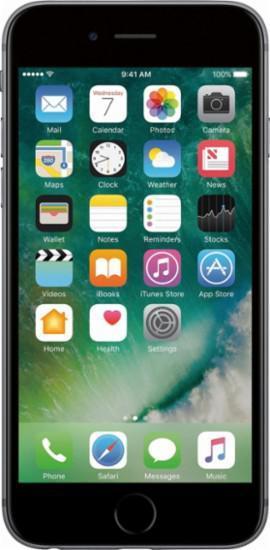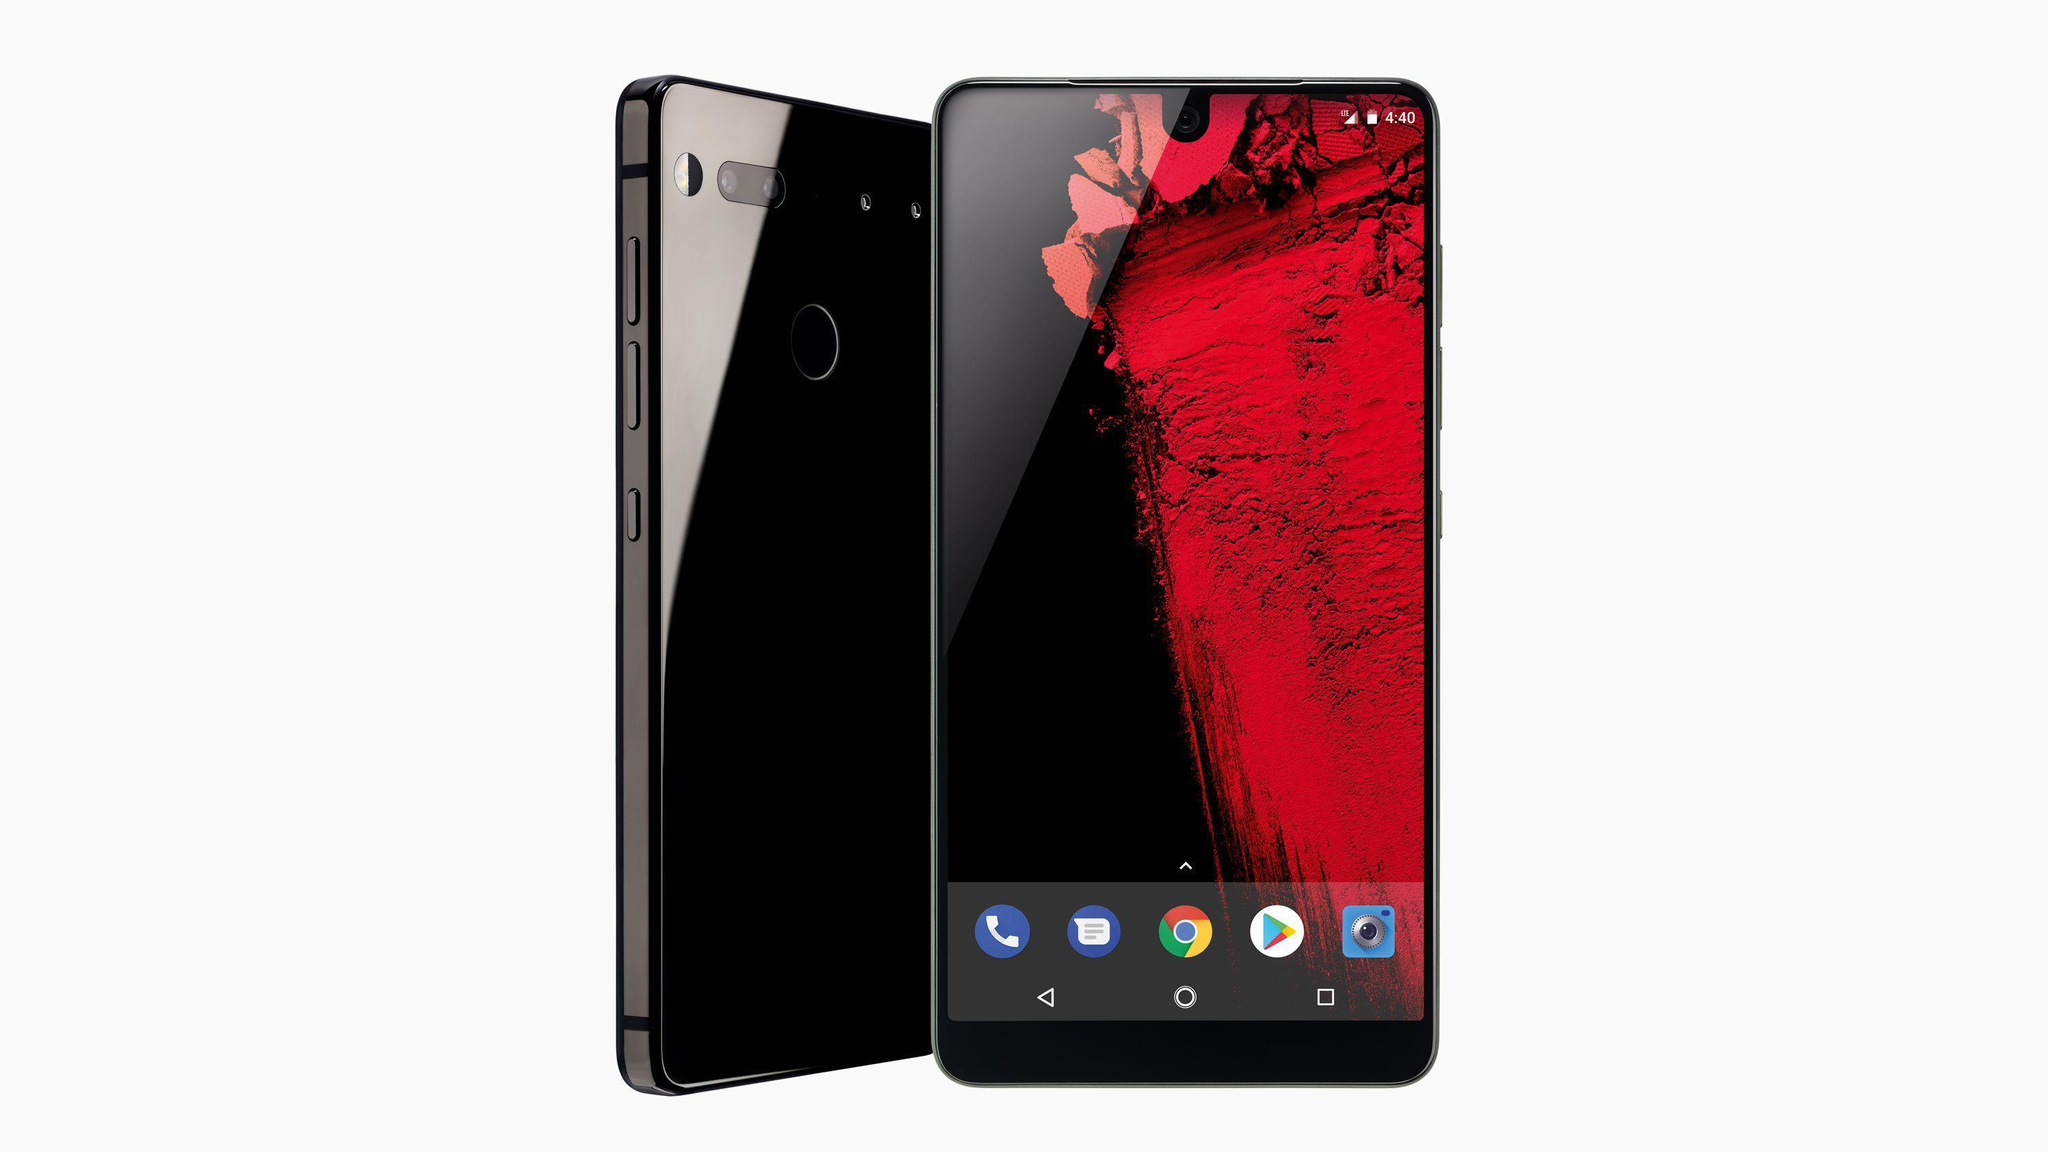The first image is the image on the left, the second image is the image on the right. Considering the images on both sides, is "Each of the images shows a female holding and looking at a cell phone." valid? Answer yes or no. No. The first image is the image on the left, the second image is the image on the right. Evaluate the accuracy of this statement regarding the images: "There are two brown haired women holding their phones.". Is it true? Answer yes or no. No. 